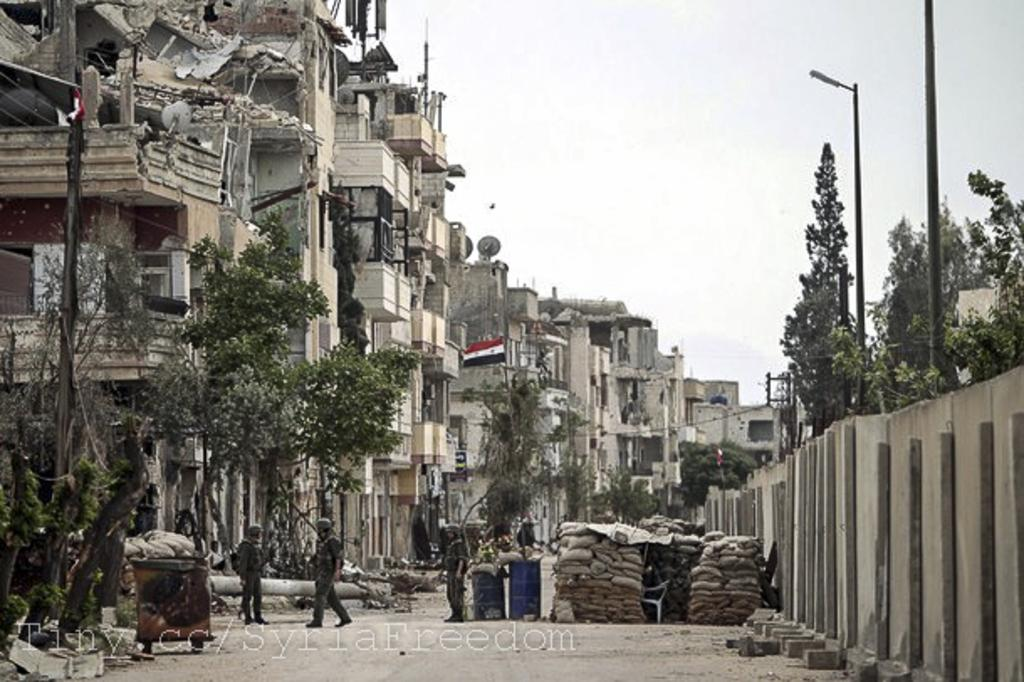Where was the image taken? The image was clicked outside. What can be seen in the middle of the image? There are trees and buildings in the middle of the image. Who or what is present at the bottom of the image? There are persons at the bottom of the image. What is visible at the top of the image? The sky is visible at the top of the image. What type of glue is being used by the girl in the image? There is no girl or glue present in the image. What type of machine can be seen operating in the image? There is no machine present in the image. 